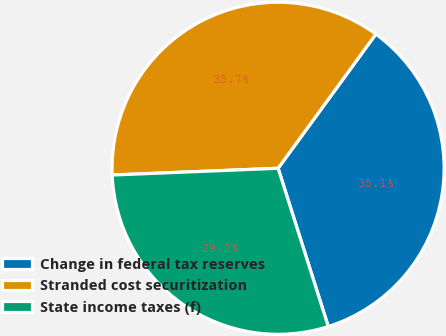Convert chart to OTSL. <chart><loc_0><loc_0><loc_500><loc_500><pie_chart><fcel>Change in federal tax reserves<fcel>Stranded cost securitization<fcel>State income taxes (f)<nl><fcel>35.09%<fcel>35.67%<fcel>29.24%<nl></chart> 